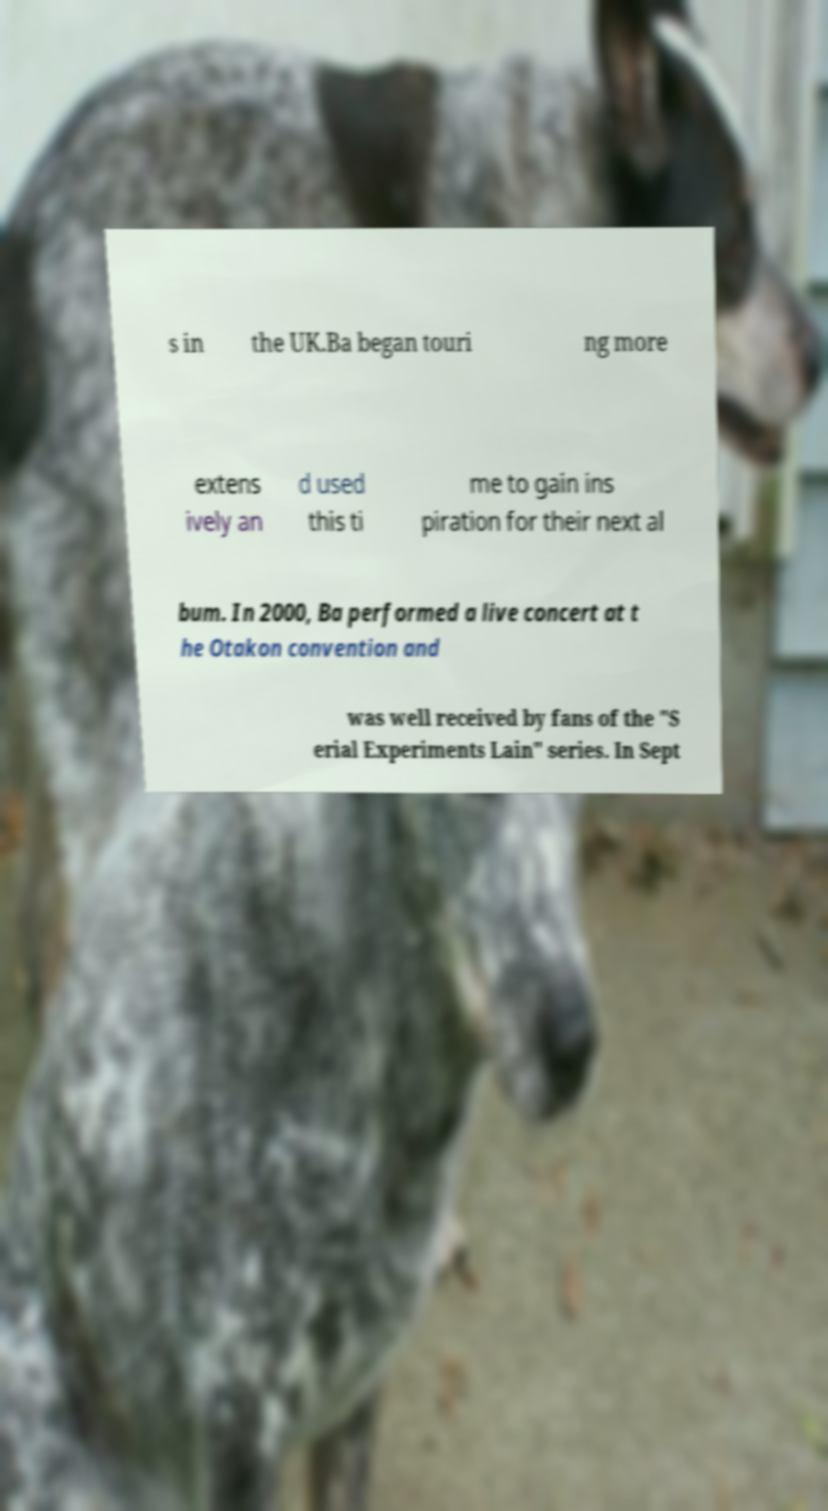Could you assist in decoding the text presented in this image and type it out clearly? s in the UK.Ba began touri ng more extens ively an d used this ti me to gain ins piration for their next al bum. In 2000, Ba performed a live concert at t he Otakon convention and was well received by fans of the "S erial Experiments Lain" series. In Sept 